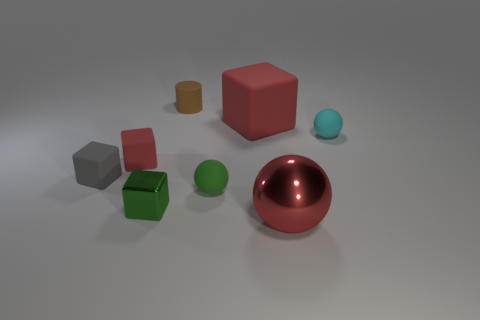Subtract all small red rubber cubes. How many cubes are left? 3 Add 1 red metal spheres. How many objects exist? 9 Subtract all green cubes. How many cubes are left? 3 Subtract all spheres. How many objects are left? 5 Subtract 3 balls. How many balls are left? 0 Subtract all green blocks. Subtract all purple cylinders. How many blocks are left? 3 Subtract all green cylinders. How many cyan balls are left? 1 Subtract all large red matte objects. Subtract all red rubber objects. How many objects are left? 5 Add 1 red metallic objects. How many red metallic objects are left? 2 Add 4 small cylinders. How many small cylinders exist? 5 